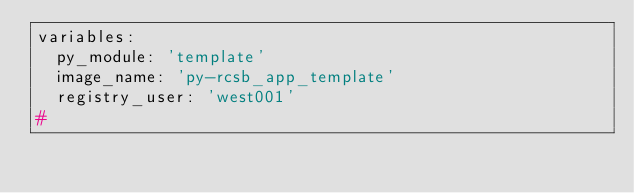Convert code to text. <code><loc_0><loc_0><loc_500><loc_500><_YAML_>variables:
  py_module: 'template'
  image_name: 'py-rcsb_app_template'
  registry_user: 'west001'
#</code> 